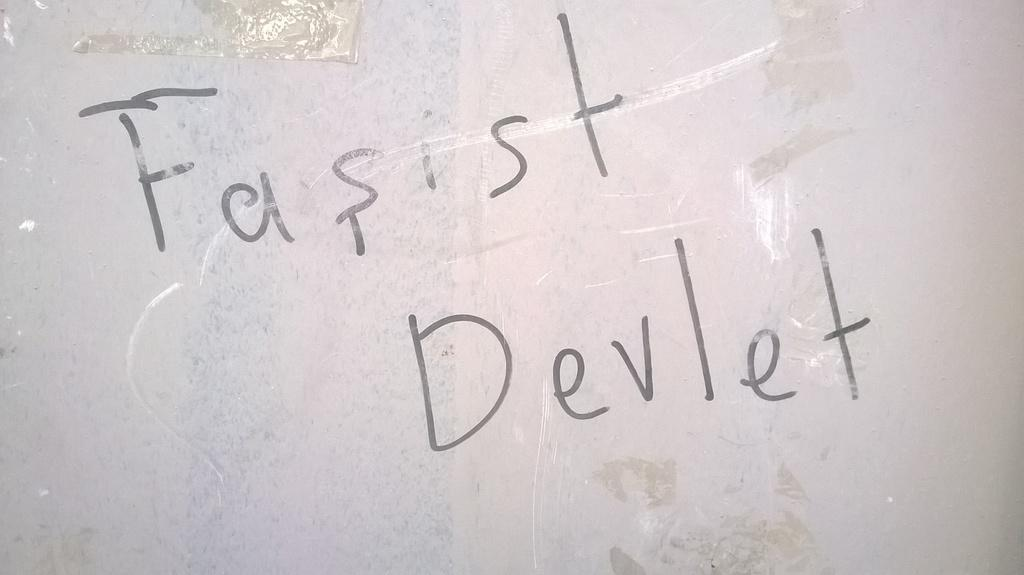<image>
Render a clear and concise summary of the photo. the word devlet that is on a white board 